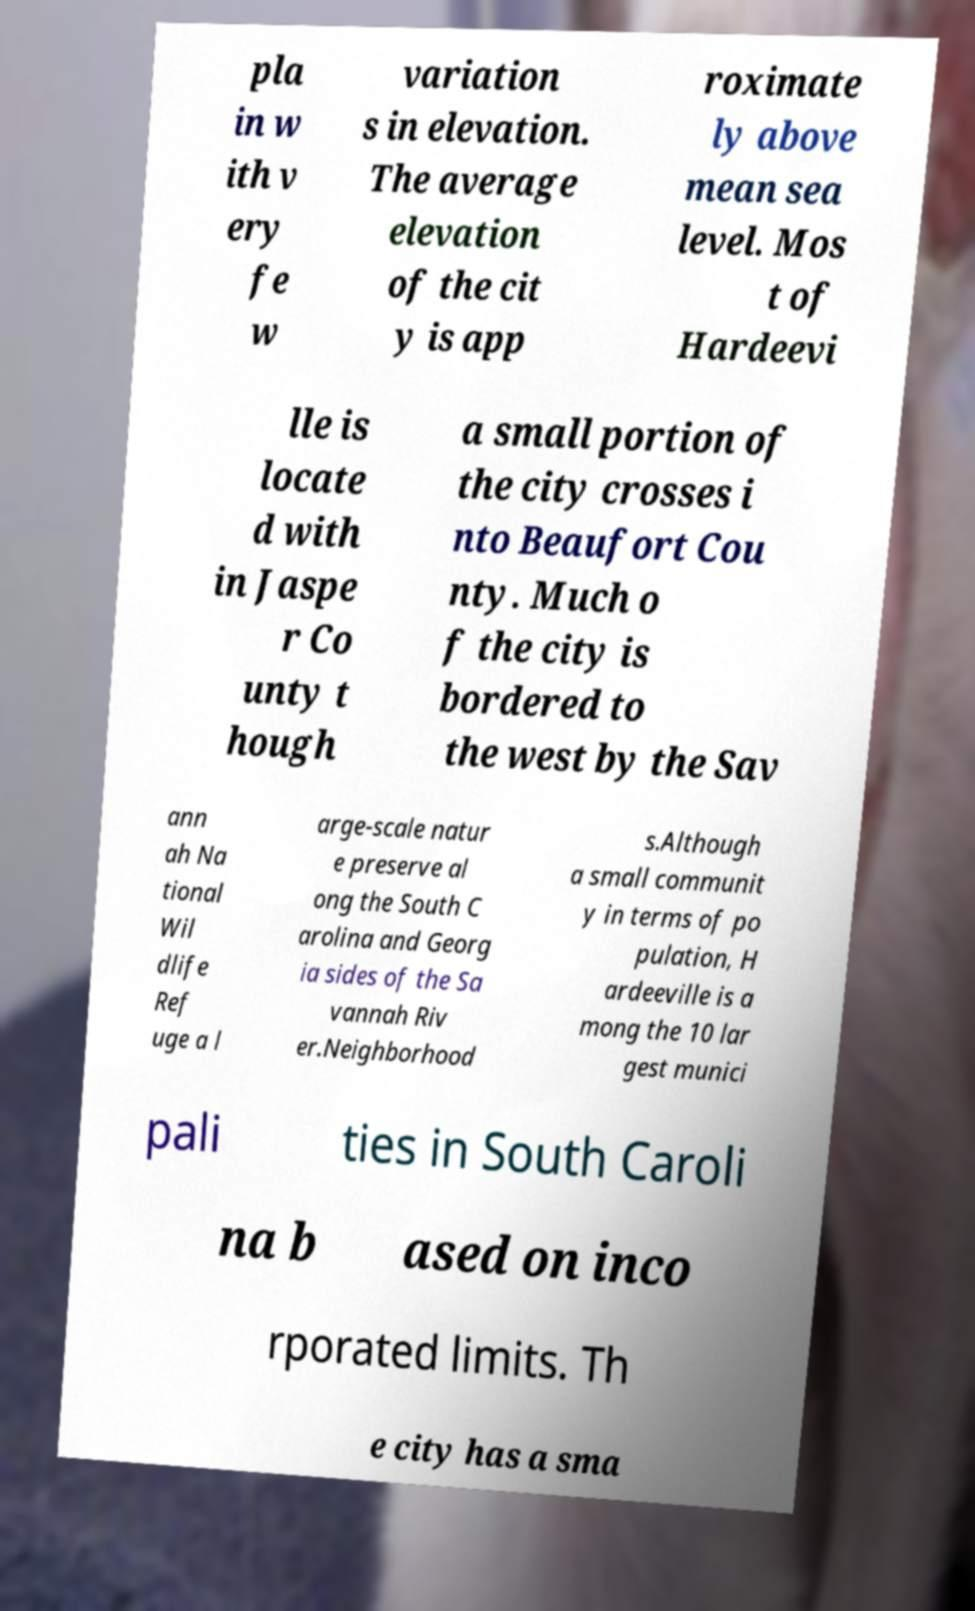Could you assist in decoding the text presented in this image and type it out clearly? pla in w ith v ery fe w variation s in elevation. The average elevation of the cit y is app roximate ly above mean sea level. Mos t of Hardeevi lle is locate d with in Jaspe r Co unty t hough a small portion of the city crosses i nto Beaufort Cou nty. Much o f the city is bordered to the west by the Sav ann ah Na tional Wil dlife Ref uge a l arge-scale natur e preserve al ong the South C arolina and Georg ia sides of the Sa vannah Riv er.Neighborhood s.Although a small communit y in terms of po pulation, H ardeeville is a mong the 10 lar gest munici pali ties in South Caroli na b ased on inco rporated limits. Th e city has a sma 